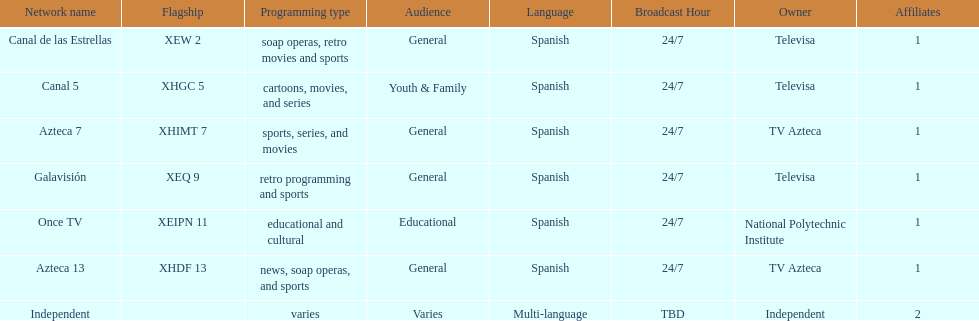What is the only network owned by national polytechnic institute? Once TV. 